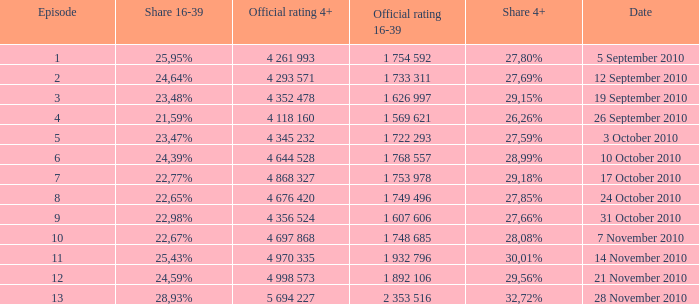Can you parse all the data within this table? {'header': ['Episode', 'Share 16-39', 'Official rating 4+', 'Official rating 16-39', 'Share 4+', 'Date'], 'rows': [['1', '25,95%', '4 261 993', '1 754 592', '27,80%', '5 September 2010'], ['2', '24,64%', '4 293 571', '1 733 311', '27,69%', '12 September 2010'], ['3', '23,48%', '4 352 478', '1 626 997', '29,15%', '19 September 2010'], ['4', '21,59%', '4 118 160', '1 569 621', '26,26%', '26 September 2010'], ['5', '23,47%', '4 345 232', '1 722 293', '27,59%', '3 October 2010'], ['6', '24,39%', '4 644 528', '1 768 557', '28,99%', '10 October 2010'], ['7', '22,77%', '4 868 327', '1 753 978', '29,18%', '17 October 2010'], ['8', '22,65%', '4 676 420', '1 749 496', '27,85%', '24 October 2010'], ['9', '22,98%', '4 356 524', '1 607 606', '27,66%', '31 October 2010'], ['10', '22,67%', '4 697 868', '1 748 685', '28,08%', '7 November 2010'], ['11', '25,43%', '4 970 335', '1 932 796', '30,01%', '14 November 2010'], ['12', '24,59%', '4 998 573', '1 892 106', '29,56%', '21 November 2010'], ['13', '28,93%', '5 694 227', '2 353 516', '32,72%', '28 November 2010']]} What is the official 4+ rating of the episode with a 16-39 share of 24,59%? 4 998 573. 